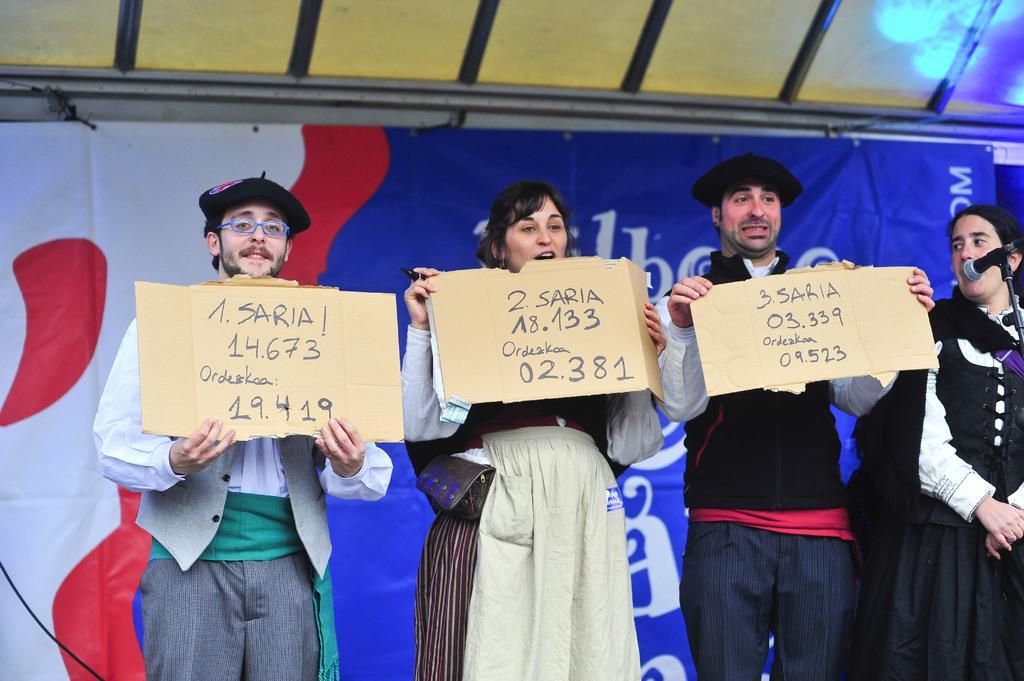Can you describe this image briefly? There are three people standing and holding placards. Man on the left side is wearing a specs and cap. On the right side a lady is standing. In front of her there is a mic and mic stand. In the back there is a banner. 